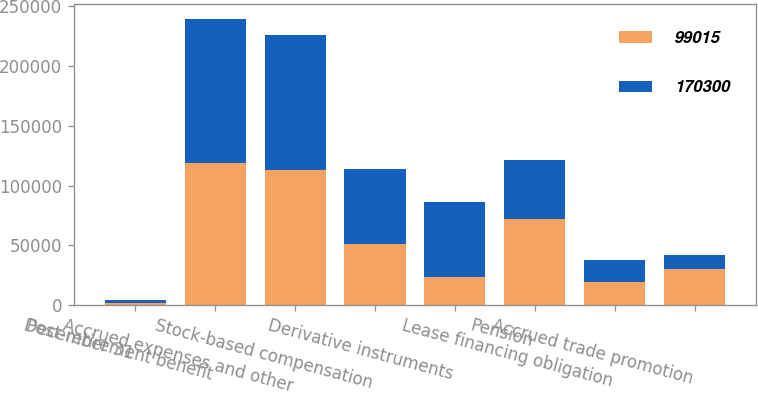Convert chart. <chart><loc_0><loc_0><loc_500><loc_500><stacked_bar_chart><ecel><fcel>December 31<fcel>Post-retirement benefit<fcel>Accrued expenses and other<fcel>Stock-based compensation<fcel>Derivative instruments<fcel>Pension<fcel>Lease financing obligation<fcel>Accrued trade promotion<nl><fcel>99015<fcel>2012<fcel>119140<fcel>112760<fcel>51388<fcel>23822<fcel>72374<fcel>19035<fcel>30594<nl><fcel>170300<fcel>2011<fcel>120174<fcel>112834<fcel>62666<fcel>62117<fcel>48884<fcel>19159<fcel>11209<nl></chart> 